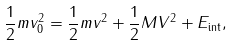<formula> <loc_0><loc_0><loc_500><loc_500>\frac { 1 } { 2 } m v _ { 0 } ^ { 2 } = \frac { 1 } { 2 } m v ^ { 2 } + \frac { 1 } { 2 } M V ^ { 2 } + E _ { \text {int} } ,</formula> 